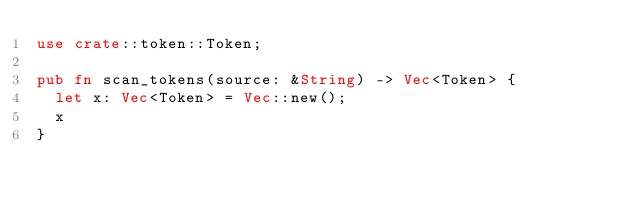<code> <loc_0><loc_0><loc_500><loc_500><_Rust_>use crate::token::Token;

pub fn scan_tokens(source: &String) -> Vec<Token> {
  let x: Vec<Token> = Vec::new();
  x
}
</code> 